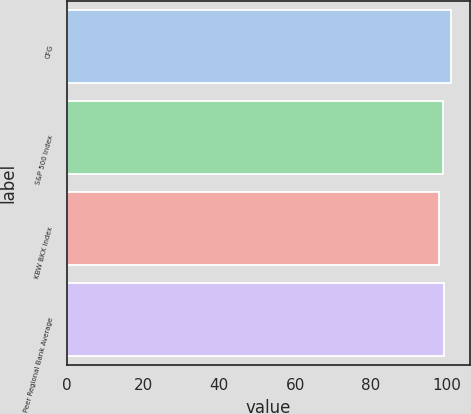Convert chart. <chart><loc_0><loc_0><loc_500><loc_500><bar_chart><fcel>CFG<fcel>S&P 500 Index<fcel>KBW BKX Index<fcel>Peer Regional Bank Average<nl><fcel>101<fcel>99<fcel>98<fcel>99.3<nl></chart> 